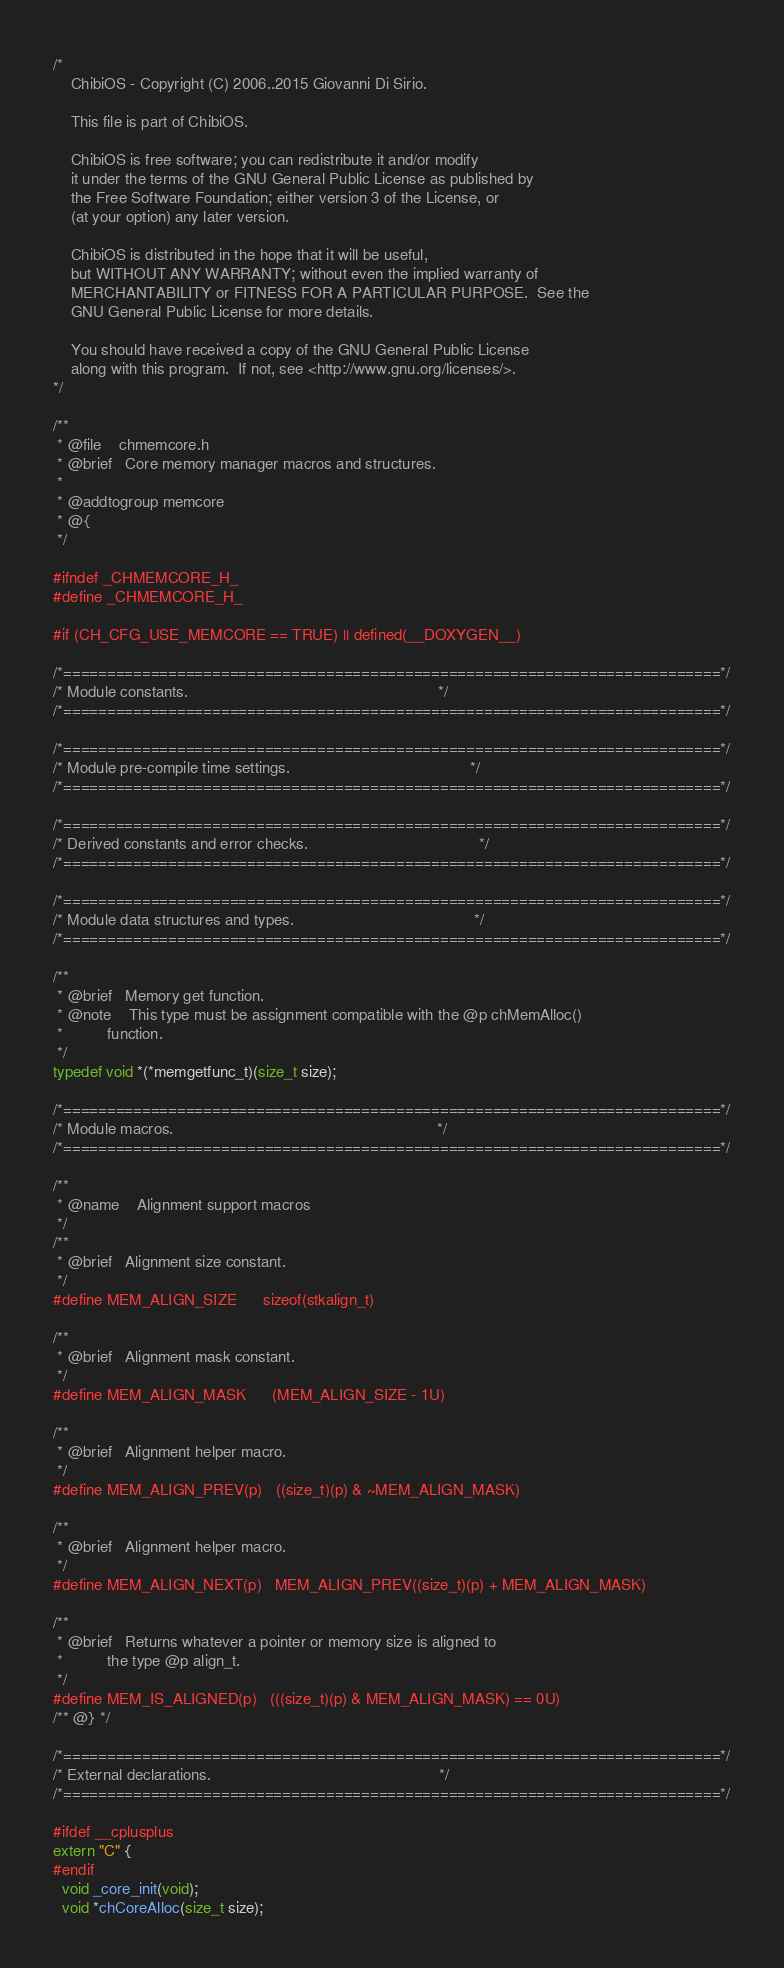Convert code to text. <code><loc_0><loc_0><loc_500><loc_500><_C_>/*
    ChibiOS - Copyright (C) 2006..2015 Giovanni Di Sirio.

    This file is part of ChibiOS.

    ChibiOS is free software; you can redistribute it and/or modify
    it under the terms of the GNU General Public License as published by
    the Free Software Foundation; either version 3 of the License, or
    (at your option) any later version.

    ChibiOS is distributed in the hope that it will be useful,
    but WITHOUT ANY WARRANTY; without even the implied warranty of
    MERCHANTABILITY or FITNESS FOR A PARTICULAR PURPOSE.  See the
    GNU General Public License for more details.

    You should have received a copy of the GNU General Public License
    along with this program.  If not, see <http://www.gnu.org/licenses/>.
*/

/**
 * @file    chmemcore.h
 * @brief   Core memory manager macros and structures.
 *
 * @addtogroup memcore
 * @{
 */

#ifndef _CHMEMCORE_H_
#define _CHMEMCORE_H_

#if (CH_CFG_USE_MEMCORE == TRUE) || defined(__DOXYGEN__)

/*===========================================================================*/
/* Module constants.                                                         */
/*===========================================================================*/

/*===========================================================================*/
/* Module pre-compile time settings.                                         */
/*===========================================================================*/

/*===========================================================================*/
/* Derived constants and error checks.                                       */
/*===========================================================================*/

/*===========================================================================*/
/* Module data structures and types.                                         */
/*===========================================================================*/

/**
 * @brief   Memory get function.
 * @note    This type must be assignment compatible with the @p chMemAlloc()
 *          function.
 */
typedef void *(*memgetfunc_t)(size_t size);

/*===========================================================================*/
/* Module macros.                                                            */
/*===========================================================================*/

/**
 * @name    Alignment support macros
 */
/**
 * @brief   Alignment size constant.
 */
#define MEM_ALIGN_SIZE      sizeof(stkalign_t)

/**
 * @brief   Alignment mask constant.
 */
#define MEM_ALIGN_MASK      (MEM_ALIGN_SIZE - 1U)

/**
 * @brief   Alignment helper macro.
 */
#define MEM_ALIGN_PREV(p)   ((size_t)(p) & ~MEM_ALIGN_MASK)

/**
 * @brief   Alignment helper macro.
 */
#define MEM_ALIGN_NEXT(p)   MEM_ALIGN_PREV((size_t)(p) + MEM_ALIGN_MASK)

/**
 * @brief   Returns whatever a pointer or memory size is aligned to
 *          the type @p align_t.
 */
#define MEM_IS_ALIGNED(p)   (((size_t)(p) & MEM_ALIGN_MASK) == 0U)
/** @} */

/*===========================================================================*/
/* External declarations.                                                    */
/*===========================================================================*/

#ifdef __cplusplus
extern "C" {
#endif
  void _core_init(void);
  void *chCoreAlloc(size_t size);</code> 